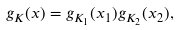Convert formula to latex. <formula><loc_0><loc_0><loc_500><loc_500>g _ { K } ( x ) = g _ { K _ { 1 } } ( x _ { 1 } ) g _ { K _ { 2 } } ( x _ { 2 } ) ,</formula> 